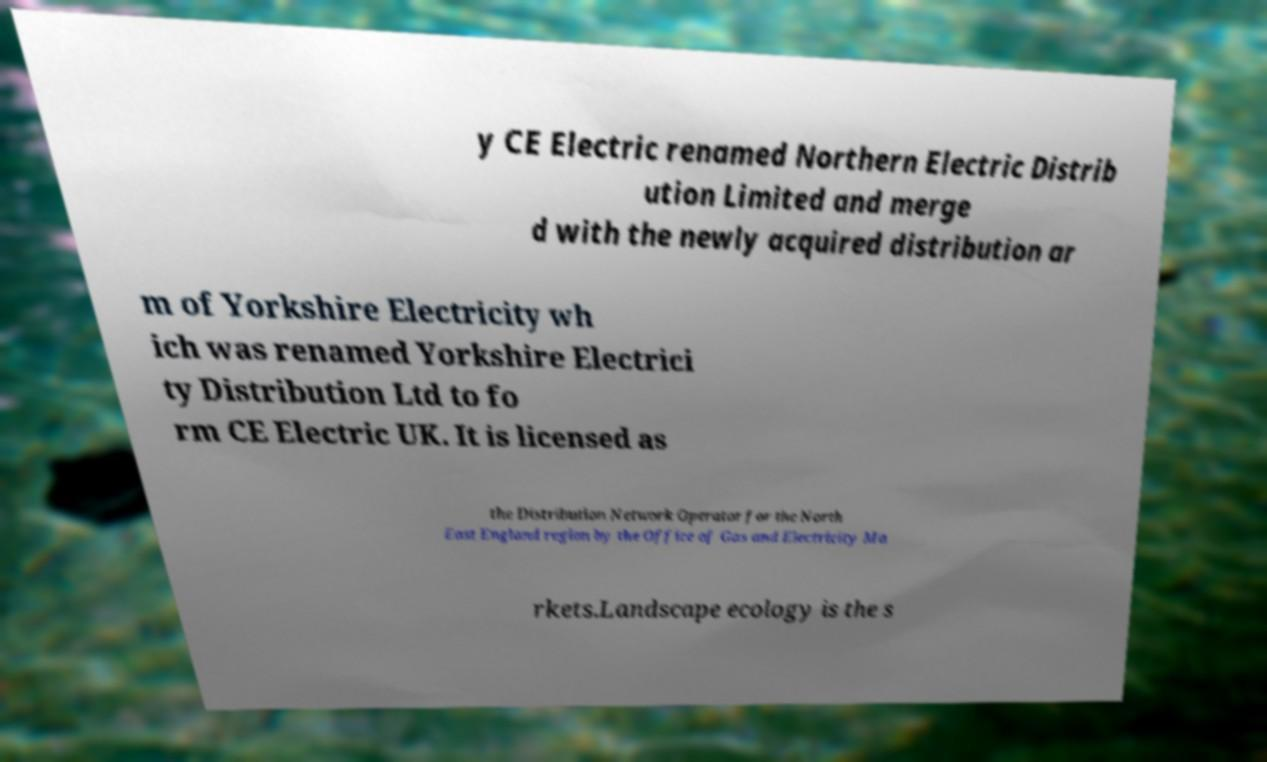What messages or text are displayed in this image? I need them in a readable, typed format. y CE Electric renamed Northern Electric Distrib ution Limited and merge d with the newly acquired distribution ar m of Yorkshire Electricity wh ich was renamed Yorkshire Electrici ty Distribution Ltd to fo rm CE Electric UK. It is licensed as the Distribution Network Operator for the North East England region by the Office of Gas and Electricity Ma rkets.Landscape ecology is the s 